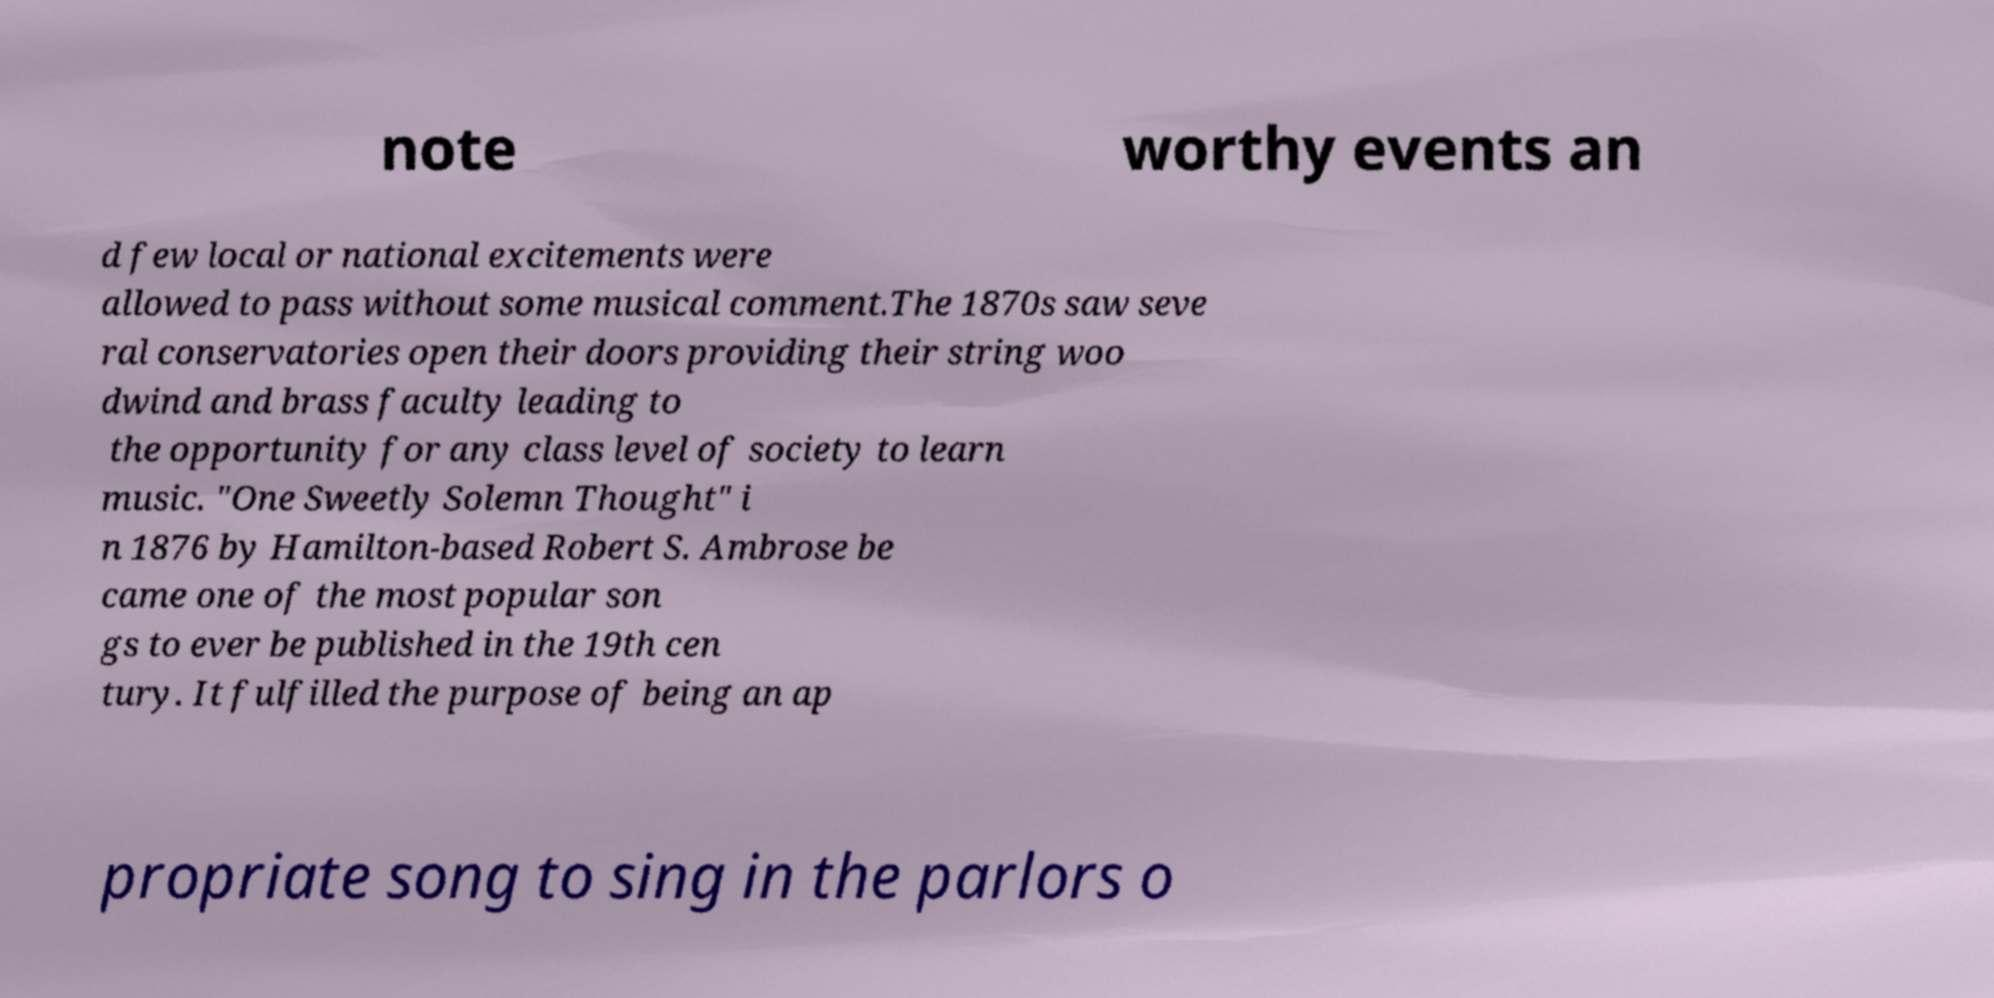I need the written content from this picture converted into text. Can you do that? note worthy events an d few local or national excitements were allowed to pass without some musical comment.The 1870s saw seve ral conservatories open their doors providing their string woo dwind and brass faculty leading to the opportunity for any class level of society to learn music. "One Sweetly Solemn Thought" i n 1876 by Hamilton-based Robert S. Ambrose be came one of the most popular son gs to ever be published in the 19th cen tury. It fulfilled the purpose of being an ap propriate song to sing in the parlors o 